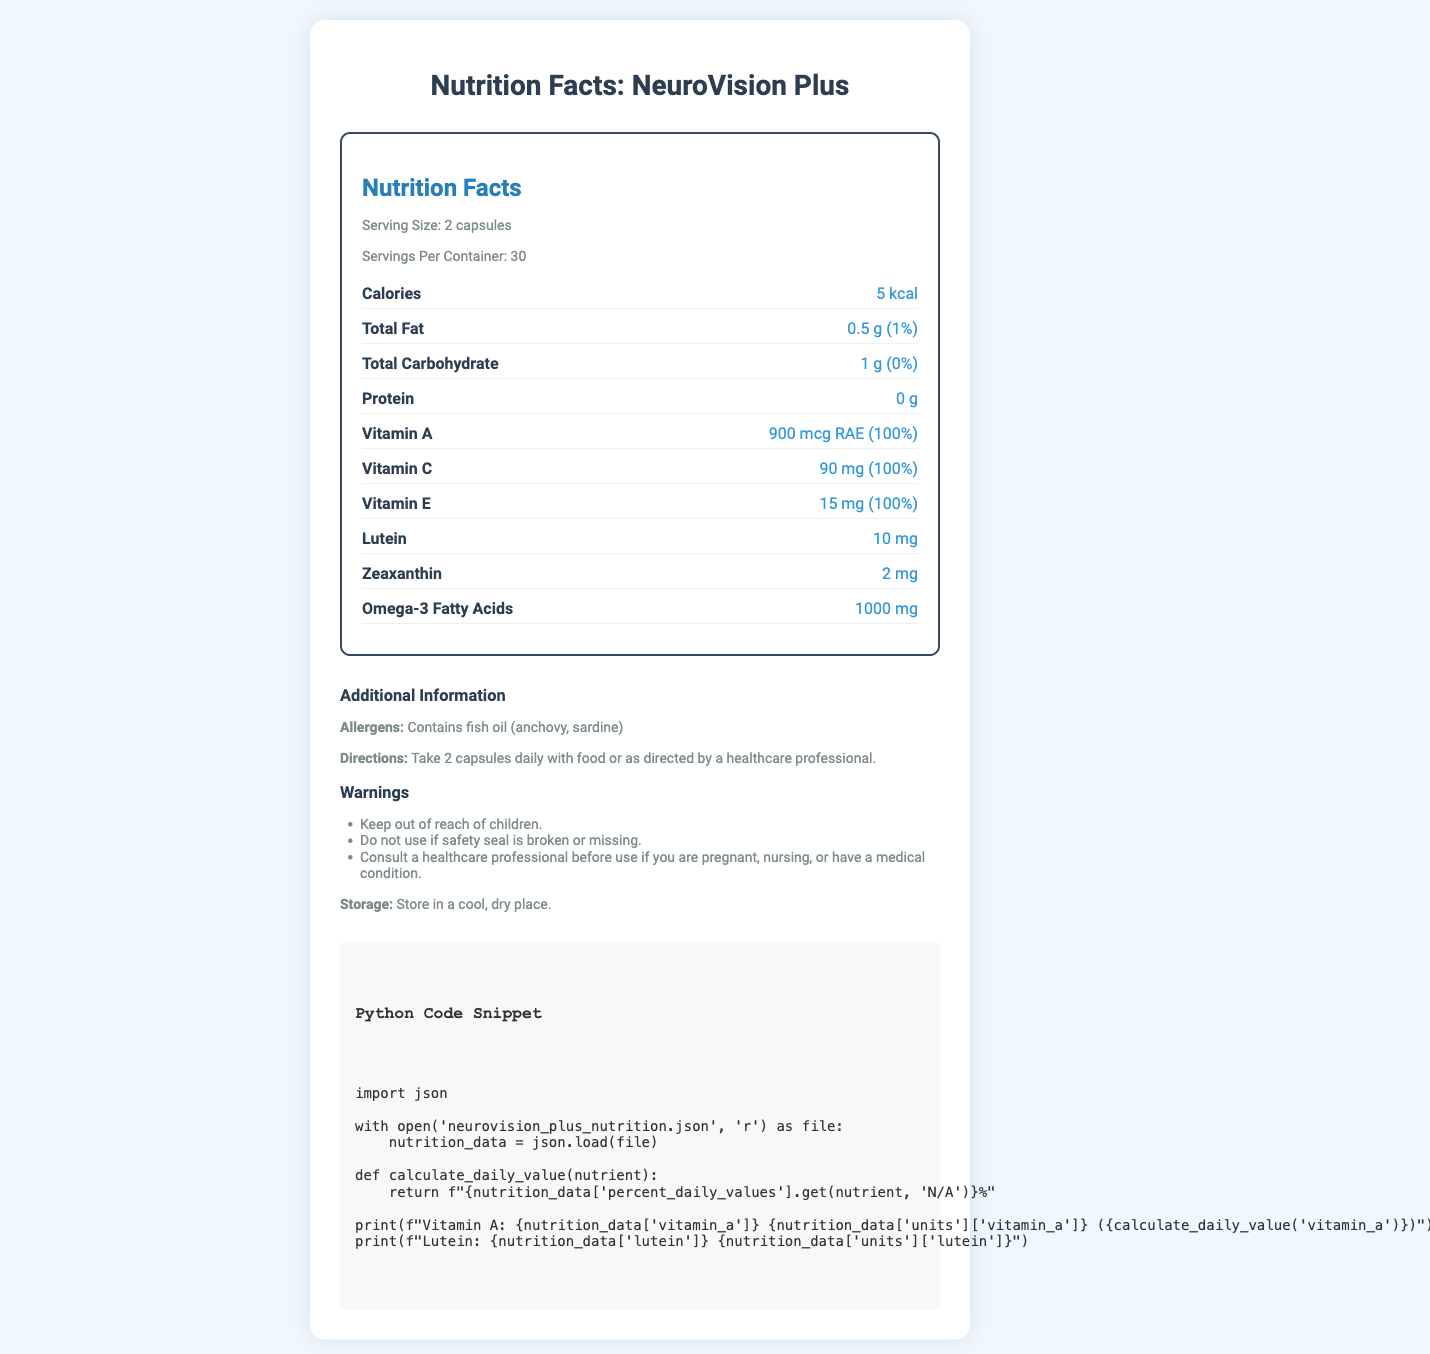What is the serving size of NeuroVision Plus? The serving size is explicitly stated as 2 capsules in the serving info section.
Answer: 2 capsules How many servings per container does NeuroVision Plus have? The servings per container are mentioned as 30 in the serving info section.
Answer: 30 How many calories are in a serving of NeuroVision Plus? The calorie content per serving is given as 5 kcal in the nutrition label.
Answer: 5 kcal What percentage of the daily value for Vitamin C does NeuroVision Plus provide? The nutrition label specifies that the product provides 100% of the daily value for Vitamin C.
Answer: 100% Does NeuroVision Plus contain any protein? The product contains 0 grams of protein, as indicated in the nutrition label.
Answer: No What allergens are listed for NeuroVision Plus? The allergens listed include fish oil derived from anchovy and sardine, mentioned under the additional information section.
Answer: Fish oil (anchovy, sardine) What is the amount of Omega-3 Fatty Acids in one serving of NeuroVision Plus? The nutrition label lists 1000 mg as the content of Omega-3 Fatty Acids per serving.
Answer: 1000 mg Which vitamin in NeuroVision Plus has the highest daily value percentage? A. Vitamin A B. Vitamin C C. Vitamin B12 D. All of the above Each of the vitamins listed (A, C, and B12) has a 100% daily value percentage as indicated in the nutrition label.
Answer: D. All of the above What is the primary function of NeuroVision Plus based on its nutrient composition? A. Immune support B. Eye health and cognitive function C. Bone health Based on the presence of nutrients like Lutein, Zeaxanthin, Omega-3 Fatty Acids, and cognitive enhancers, the primary function is eye health and cognitive function.
Answer: B. Eye health and cognitive function Should you consult a healthcare professional before using NeuroVision Plus if you are pregnant? The additional info section includes a warning advising consultation with a healthcare professional for pregnant women.
Answer: Yes Is the product safe for children to use? The warnings section clearly states to keep the product out of reach of children.
Answer: No What is the main idea of the document? The document mainly outlines the serving size, nutrient content, daily value percentages, allergens, directions for use, warnings, and storage instructions for the NeuroVision Plus supplement.
Answer: The document provides detailed nutritional information, serving size, and additional details about NeuroVision Plus, a vitamin supplement for eye health and cognitive function. How much Lutein does NeuroVision Plus contain? The nutrient acronym RAE for Vitamin A is not explained in the document, so its exact meaning cannot be determined from the visual information alone.
Answer: Cannot be determined 